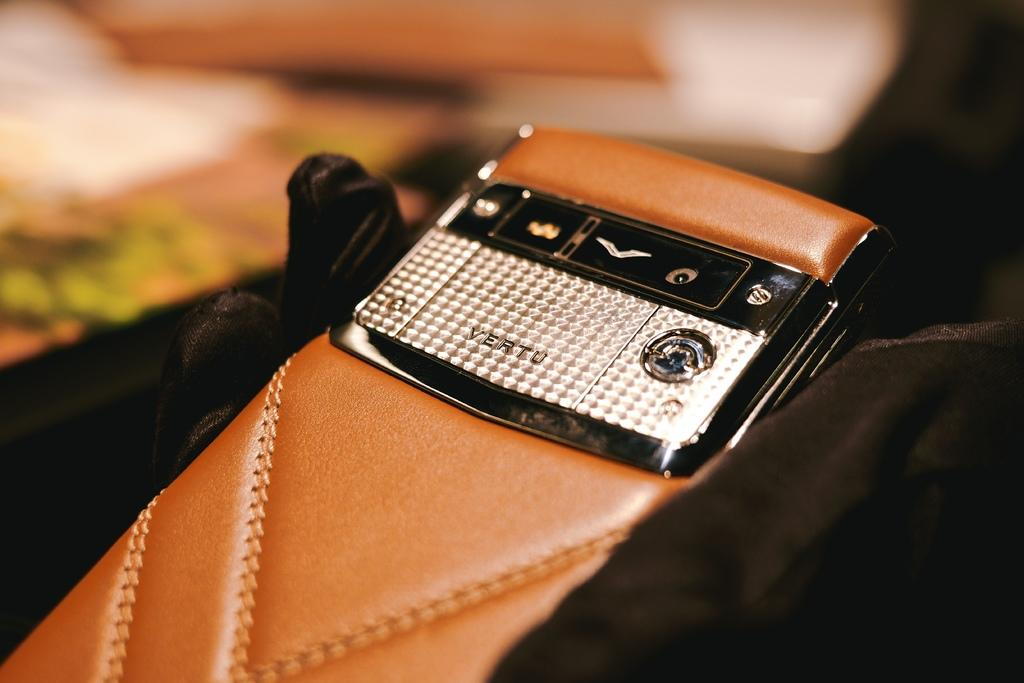What object is the main subject of the image? There is a mobile in the image. What material is used for the back cover of the mobile? The mobile has a leather back cover. On what surface is the mobile placed? The mobile is placed on a black cloth. How would you describe the background of the image? The background of the image is blurred. What type of cabbage can be seen in the image? There is no cabbage present in the image. Is there a cast or crew visible in the image? There is no cast or crew visible in the image; it is a picture of a mobile. Can you see any ghosts in the image? There are no ghosts present in the image. 